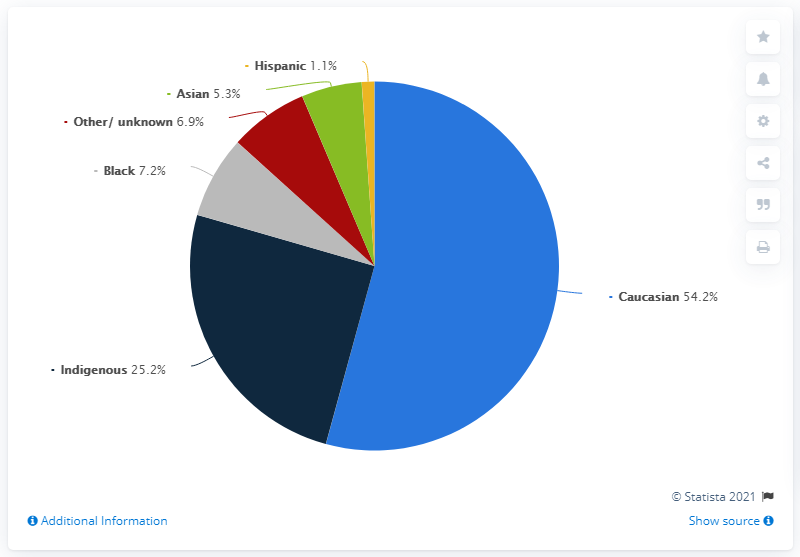Highlight a few significant elements in this photo. In the fiscal year of 2019, 54.2% of the adult offender population in federal correctional services in Canada were Caucasian. The majority of people in the chart are Caucasian. According to the data provided, the percentage values for black and Hispanic individuals are [7.2, 5.3]. 